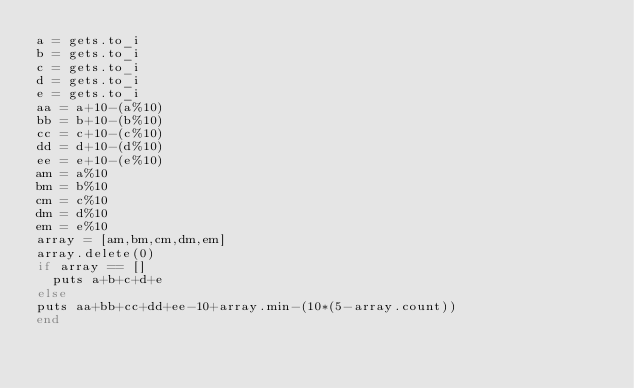<code> <loc_0><loc_0><loc_500><loc_500><_Ruby_>a = gets.to_i
b = gets.to_i
c = gets.to_i
d = gets.to_i
e = gets.to_i
aa = a+10-(a%10)
bb = b+10-(b%10)
cc = c+10-(c%10)
dd = d+10-(d%10)
ee = e+10-(e%10)
am = a%10
bm = b%10
cm = c%10
dm = d%10
em = e%10
array = [am,bm,cm,dm,em]
array.delete(0)
if array == []
  puts a+b+c+d+e
else
puts aa+bb+cc+dd+ee-10+array.min-(10*(5-array.count))
end</code> 